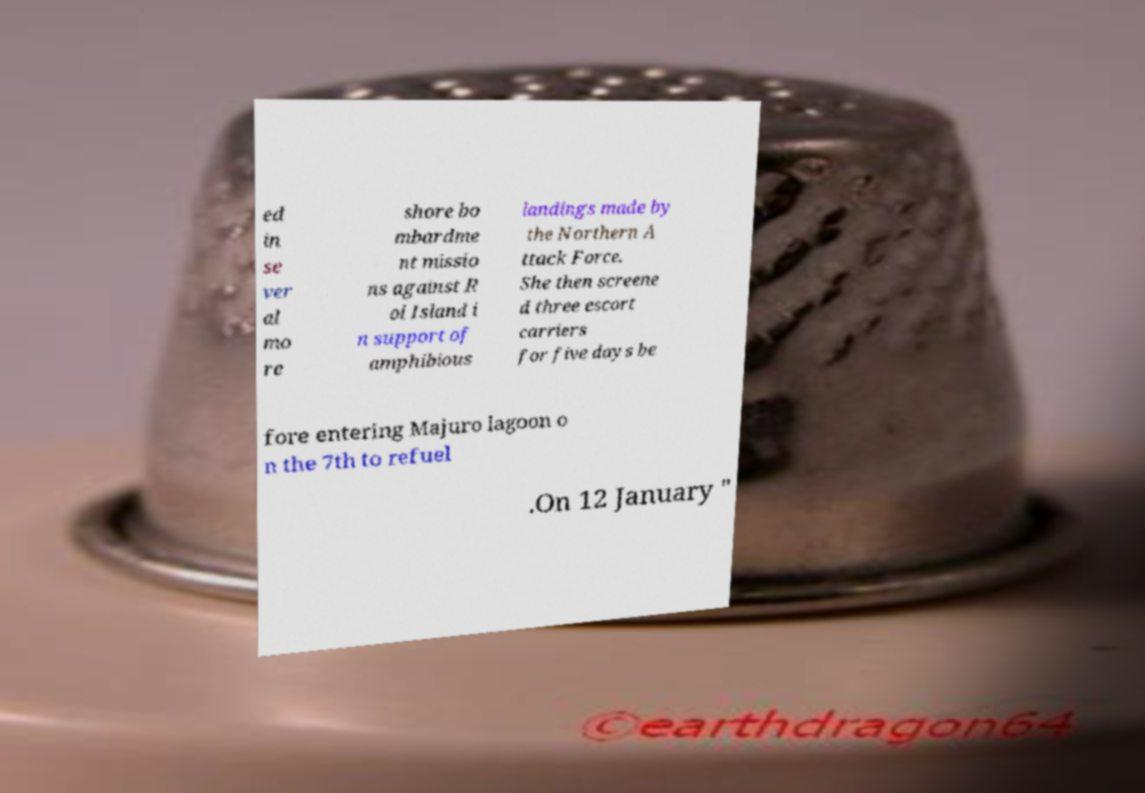Can you accurately transcribe the text from the provided image for me? ed in se ver al mo re shore bo mbardme nt missio ns against R oi Island i n support of amphibious landings made by the Northern A ttack Force. She then screene d three escort carriers for five days be fore entering Majuro lagoon o n the 7th to refuel .On 12 January " 